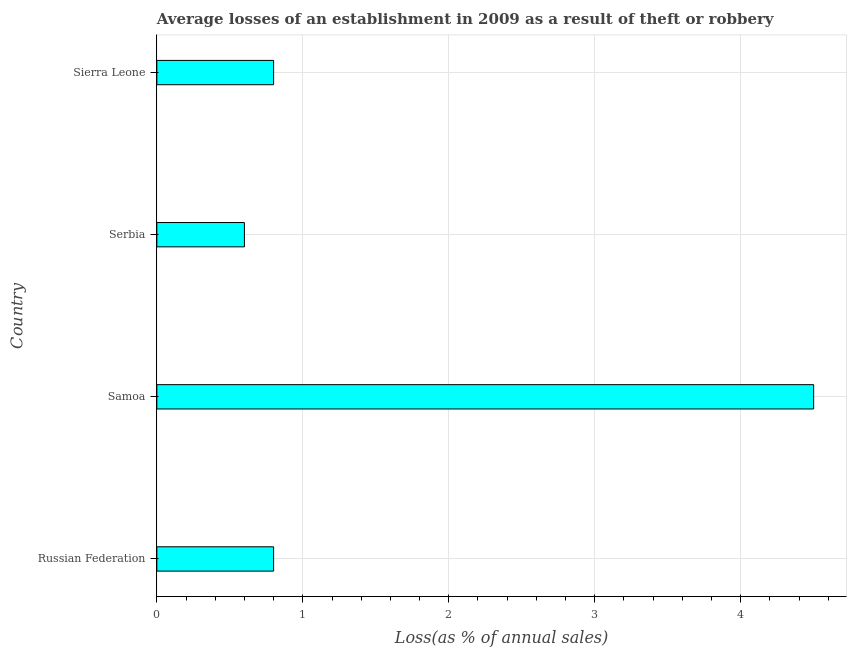Does the graph contain any zero values?
Offer a very short reply. No. Does the graph contain grids?
Provide a short and direct response. Yes. What is the title of the graph?
Your answer should be very brief. Average losses of an establishment in 2009 as a result of theft or robbery. What is the label or title of the X-axis?
Provide a succinct answer. Loss(as % of annual sales). What is the losses due to theft in Serbia?
Your answer should be very brief. 0.6. Across all countries, what is the minimum losses due to theft?
Offer a terse response. 0.6. In which country was the losses due to theft maximum?
Offer a very short reply. Samoa. In which country was the losses due to theft minimum?
Your answer should be very brief. Serbia. What is the sum of the losses due to theft?
Make the answer very short. 6.7. What is the average losses due to theft per country?
Give a very brief answer. 1.68. What is the median losses due to theft?
Your answer should be compact. 0.8. Is the sum of the losses due to theft in Samoa and Serbia greater than the maximum losses due to theft across all countries?
Provide a short and direct response. Yes. What is the difference between the highest and the lowest losses due to theft?
Provide a succinct answer. 3.9. In how many countries, is the losses due to theft greater than the average losses due to theft taken over all countries?
Make the answer very short. 1. How many bars are there?
Provide a short and direct response. 4. Are all the bars in the graph horizontal?
Offer a very short reply. Yes. How many countries are there in the graph?
Ensure brevity in your answer.  4. Are the values on the major ticks of X-axis written in scientific E-notation?
Give a very brief answer. No. What is the Loss(as % of annual sales) of Samoa?
Offer a very short reply. 4.5. What is the difference between the Loss(as % of annual sales) in Russian Federation and Samoa?
Offer a very short reply. -3.7. What is the difference between the Loss(as % of annual sales) in Russian Federation and Serbia?
Offer a terse response. 0.2. What is the difference between the Loss(as % of annual sales) in Samoa and Serbia?
Keep it short and to the point. 3.9. What is the ratio of the Loss(as % of annual sales) in Russian Federation to that in Samoa?
Your response must be concise. 0.18. What is the ratio of the Loss(as % of annual sales) in Russian Federation to that in Serbia?
Give a very brief answer. 1.33. What is the ratio of the Loss(as % of annual sales) in Russian Federation to that in Sierra Leone?
Provide a short and direct response. 1. What is the ratio of the Loss(as % of annual sales) in Samoa to that in Sierra Leone?
Ensure brevity in your answer.  5.62. 